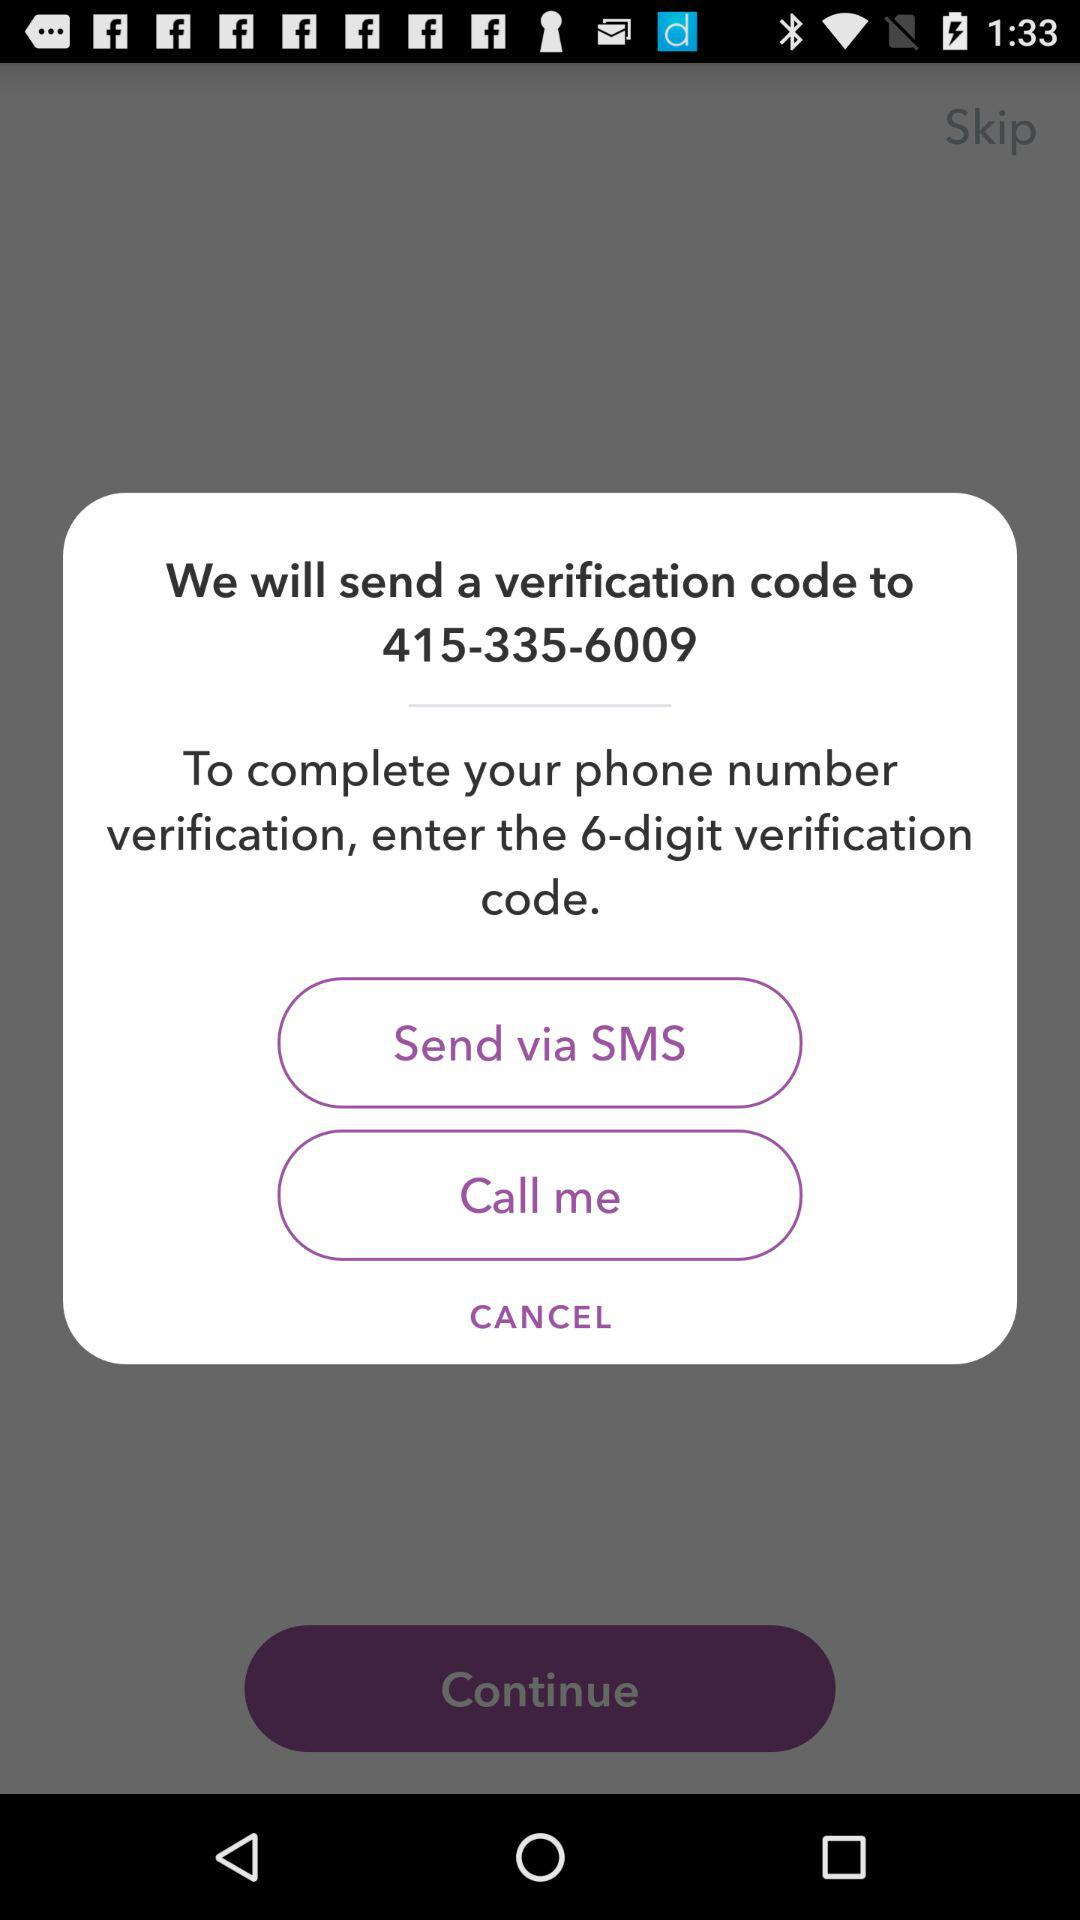To what phone number will the verification code be sent? The phone number is 415-335-6009. 